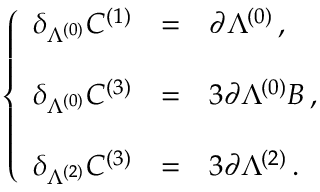Convert formula to latex. <formula><loc_0><loc_0><loc_500><loc_500>\left \{ \begin{array} { r c l } { { \delta _ { \Lambda ^ { ( 0 ) } } C ^ { ( 1 ) } } } & { = } & { { \partial \Lambda ^ { ( 0 ) } \, , } } \\ { { \delta _ { \Lambda ^ { ( 0 ) } } C ^ { ( 3 ) } } } & { = } & { { 3 \partial \Lambda ^ { ( 0 ) } B \, , } } \\ { { \delta _ { \Lambda ^ { ( 2 ) } } C ^ { ( 3 ) } } } & { = } & { { 3 \partial \Lambda ^ { ( 2 ) } \, . } } \end{array}</formula> 